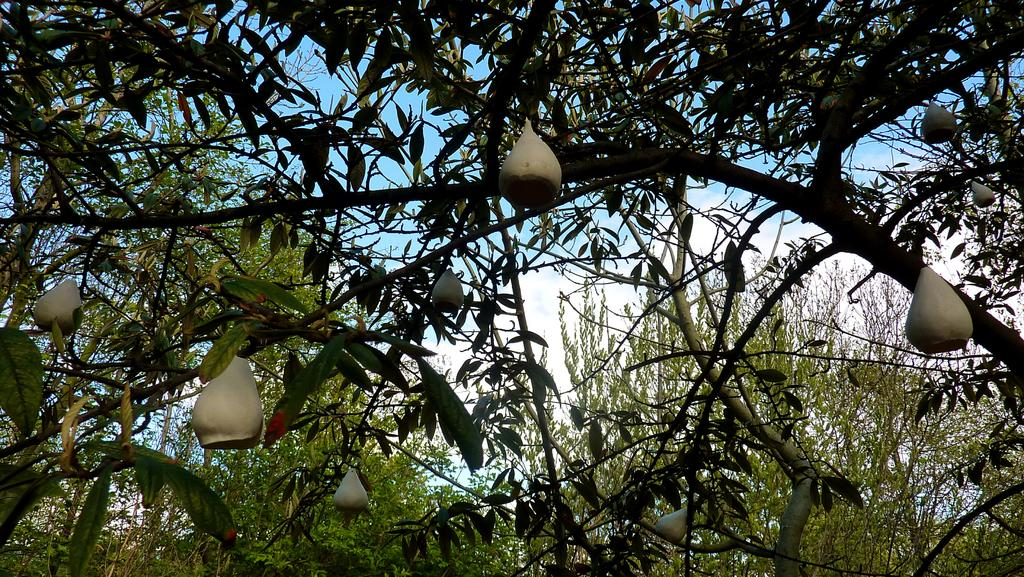What is located in the foreground of the image? There is a tree with fruits in the foreground of the image. What can be seen in the background of the image? There are trees and the sky visible in the background of the image. What is the condition of the sky in the image? The sky is visible in the background of the image, and there is a cloud present. What type of pin can be seen holding the tree branches together in the image? There is no pin present in the image; the tree branches are held together naturally. What religion is being practiced by the passengers in the image? There are no passengers present in the image, so it is not possible to determine their religion. 